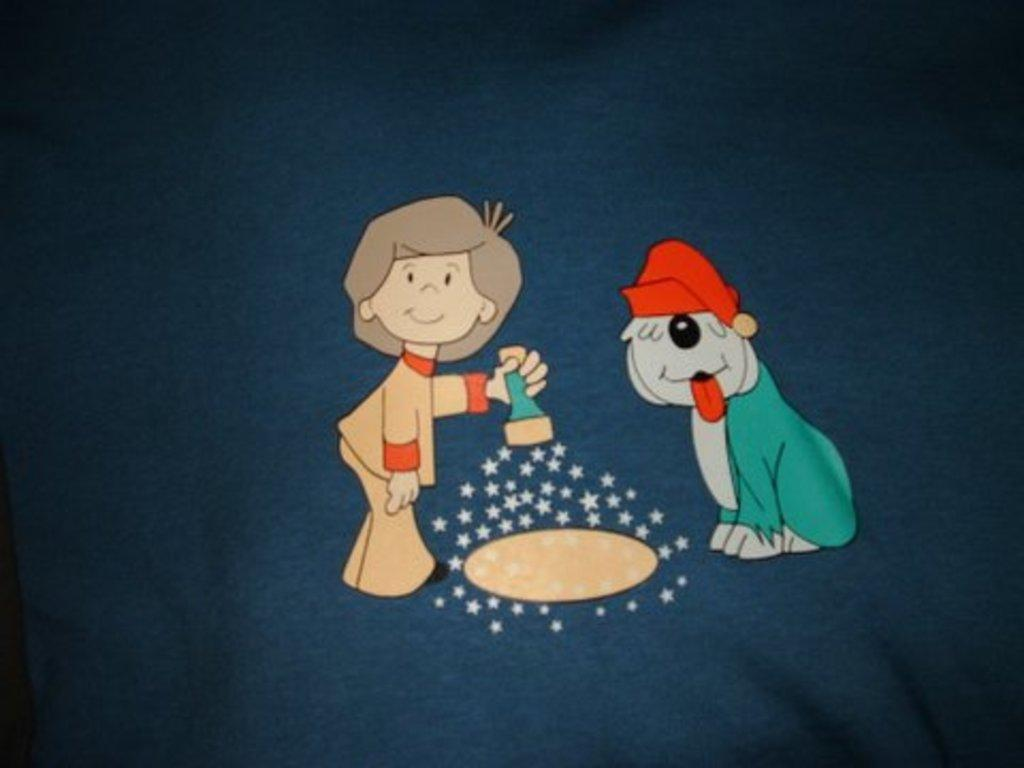What type of image is being described? The image is animated. What animal is present in the image? There is a dog in the image. Who else is present in the image? There is a girl in the image. What is the girl holding in the image? The girl is holding a torch. What type of quartz can be seen in the girl's hand in the image? There is no quartz present in the image; the girl is holding a torch. What is the girl's tendency to use the torch for in the image? The image does not provide information about the girl's tendency to use the torch for any specific purpose. 